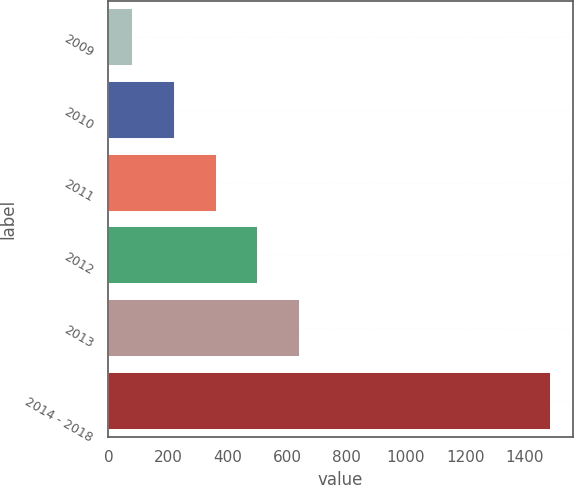<chart> <loc_0><loc_0><loc_500><loc_500><bar_chart><fcel>2009<fcel>2010<fcel>2011<fcel>2012<fcel>2013<fcel>2014 - 2018<nl><fcel>83<fcel>223.3<fcel>363.6<fcel>503.9<fcel>644.2<fcel>1486<nl></chart> 